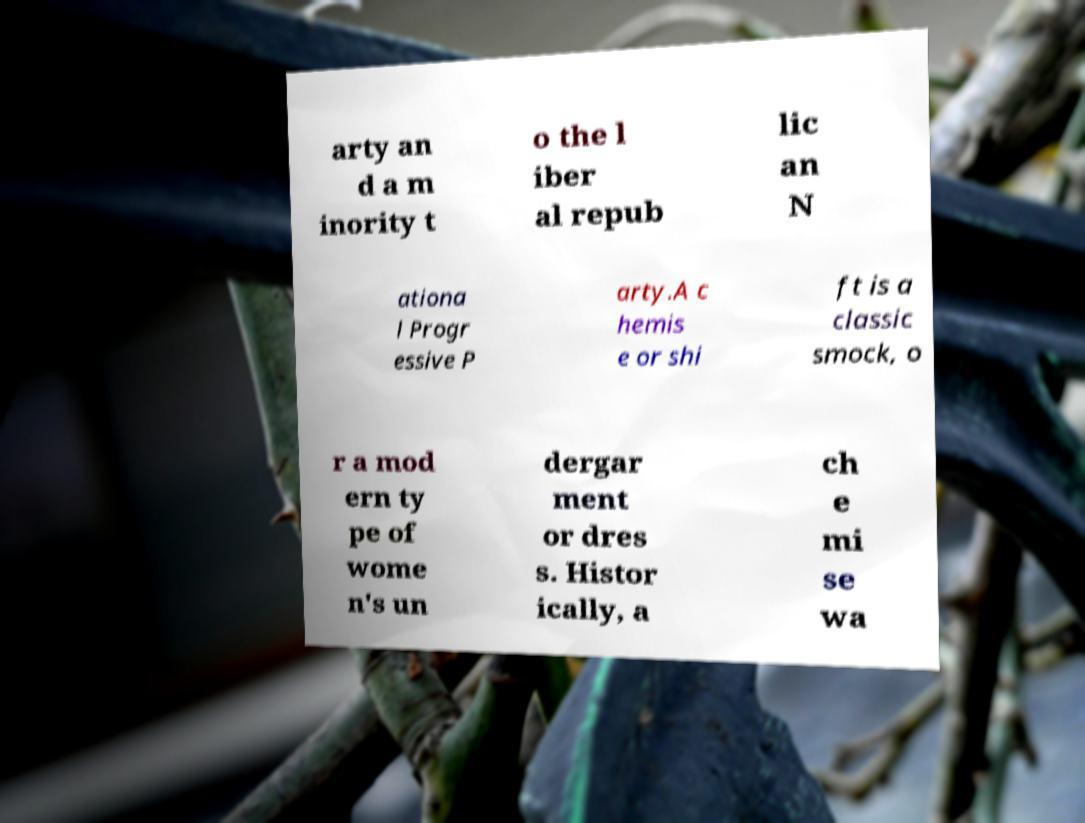Could you extract and type out the text from this image? arty an d a m inority t o the l iber al repub lic an N ationa l Progr essive P arty.A c hemis e or shi ft is a classic smock, o r a mod ern ty pe of wome n's un dergar ment or dres s. Histor ically, a ch e mi se wa 